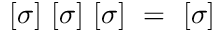Convert formula to latex. <formula><loc_0><loc_0><loc_500><loc_500>[ \sigma ] [ \sigma ] [ \sigma ] = [ \sigma ]</formula> 